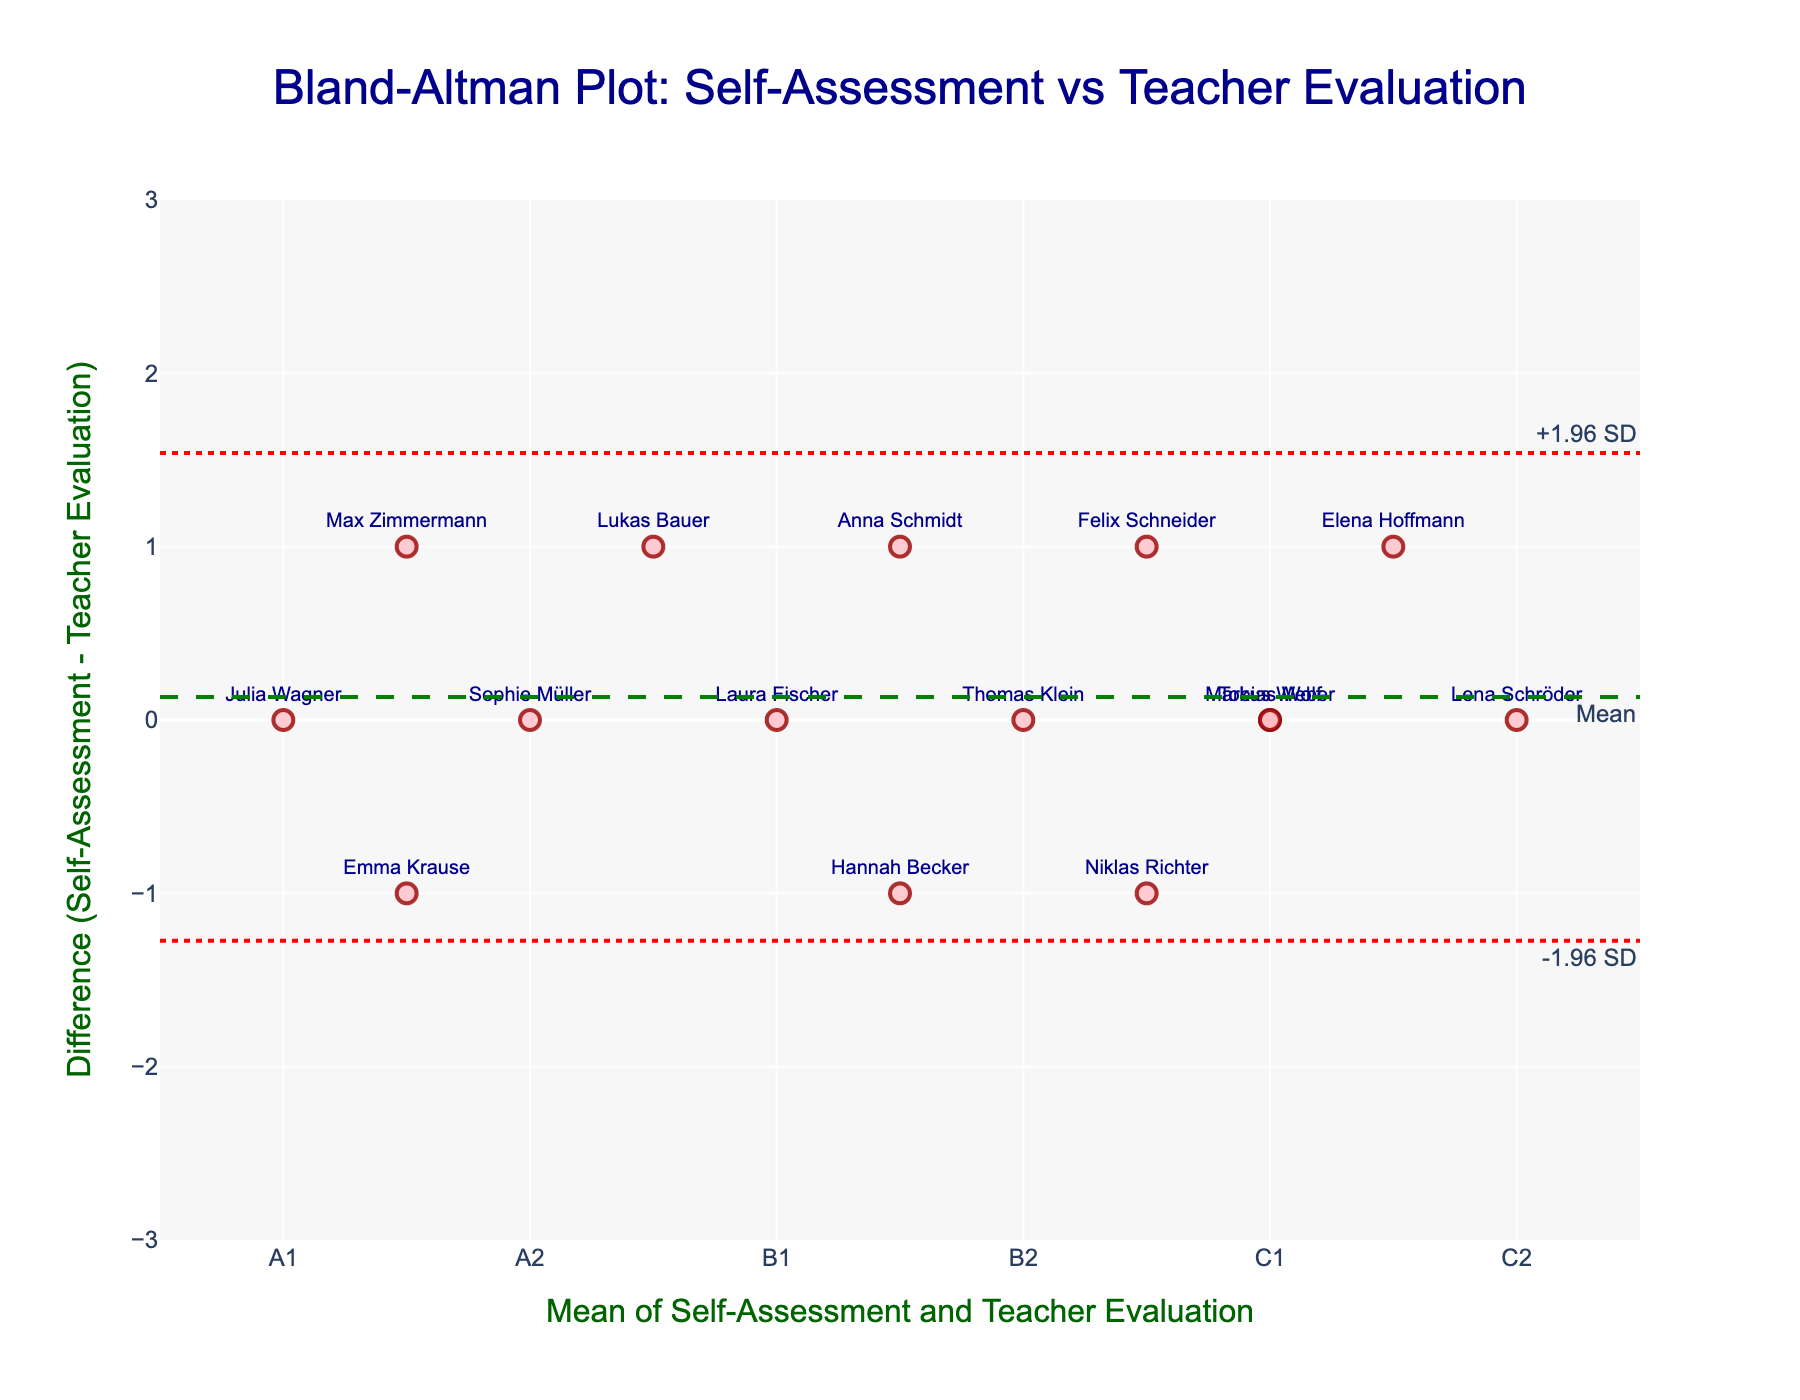What's the title of the plot? The title is displayed at the top of the plot and usually provides a summary of what the plot represents. In this case, it is a Bland-Altman plot comparing self-assessed and teacher-evaluated German language proficiency levels.
Answer: Bland-Altman Plot: Self-Assessment vs Teacher Evaluation What does the x-axis represent? The x-axis label explains what the axis represents, which is the mean of self-assessment and teacher evaluation in this plot. This is depicted through the axis title "Mean of Self-Assessment and Teacher Evaluation".
Answer: Mean of Self-Assessment and Teacher Evaluation How many students are plotted in the graph? Each data point on the scatter plot represents a student. By counting the number of data points labeled with student names, we can find the total number of students. There are 15 students labeled on the plot.
Answer: 15 What does the y-axis represent? The y-axis label describes what the axis represents. In this plot, it shows the difference between self-assessment and teacher evaluation scores, which is labeled as "Difference (Self-Assessment - Teacher Evaluation)".
Answer: Difference (Self-Assessment - Teacher Evaluation) Which student has the largest positive difference between self-assessment and teacher evaluation? To find the student with the largest positive difference, look for the data point with the highest value on the y-axis. The plot shows the names of the students, and the highest positive difference is for Niklas Richter.
Answer: Niklas Richter What are the upper and lower limits of agreement? The limits of agreement are represented by the dashed red lines labeled "+1.96 SD" and "-1.96 SD" on the plot. These lines indicate the range within which most differences between self-assessment and teacher evaluation fall. The upper limit is approximately 1.8, and the lower limit is approximately -1.8.
Answer: Upper limit: 1.8, Lower limit: -1.8 Which students have a negative difference between self-assessment and teacher evaluation? To identify students with a negative difference, look for data points below the zero line on the y-axis. The students with negative differences are Elena Hoffmann, Lukas Bauer, Anna Schmidt, and Max Zimmermann.
Answer: Elena Hoffmann, Lukas Bauer, Anna Schmidt, Max Zimmermann What is the average of the differences between self-assessment and teacher evaluation for all students? The plot includes a green dashed line representing the mean difference across all students, annotated as "Mean". This mean difference is approximately -0.067.
Answer: -0.067 Which student’s self-assessment closely matches the teacher evaluation? To find closely matching scores, look for data points near the zero value on the y-axis. The students whose self-assessment almost equals the teacher evaluation are Markus Weber, Sophie Müller, Thomas Klein, Laura Fischer, Lena Schröder, and Tobias Wolf.
Answer: Markus Weber, Sophie Müller, Thomas Klein, Laura Fischer, Lena Schröder, Tobias Wolf 